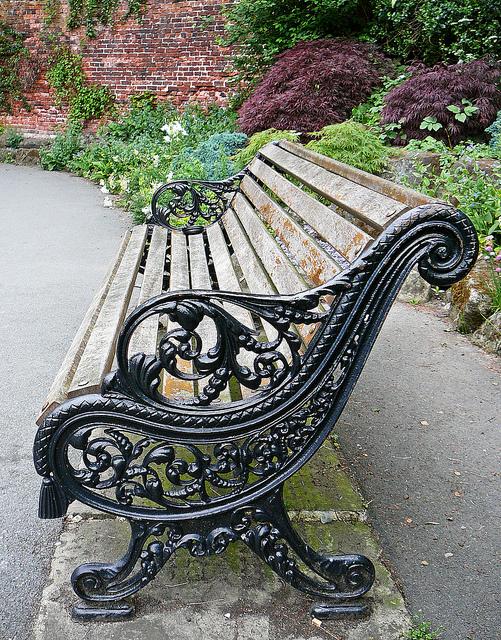What is the benchmade off?
Be succinct. Wood. What is the building made of?
Concise answer only. Brick. What is underneath the bench?
Answer briefly. Cement. 